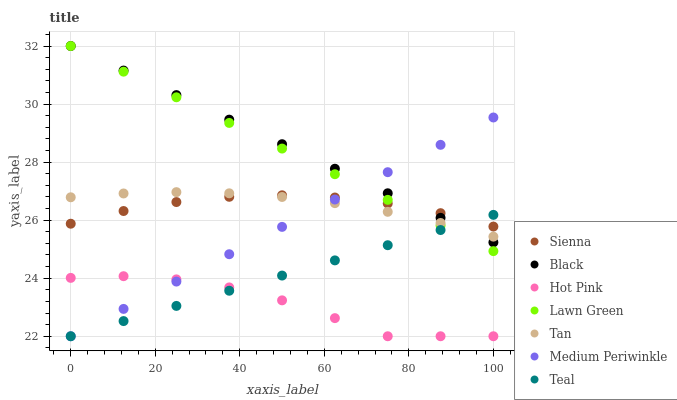Does Hot Pink have the minimum area under the curve?
Answer yes or no. Yes. Does Black have the maximum area under the curve?
Answer yes or no. Yes. Does Medium Periwinkle have the minimum area under the curve?
Answer yes or no. No. Does Medium Periwinkle have the maximum area under the curve?
Answer yes or no. No. Is Teal the smoothest?
Answer yes or no. Yes. Is Hot Pink the roughest?
Answer yes or no. Yes. Is Medium Periwinkle the smoothest?
Answer yes or no. No. Is Medium Periwinkle the roughest?
Answer yes or no. No. Does Hot Pink have the lowest value?
Answer yes or no. Yes. Does Sienna have the lowest value?
Answer yes or no. No. Does Black have the highest value?
Answer yes or no. Yes. Does Medium Periwinkle have the highest value?
Answer yes or no. No. Is Hot Pink less than Tan?
Answer yes or no. Yes. Is Sienna greater than Hot Pink?
Answer yes or no. Yes. Does Medium Periwinkle intersect Tan?
Answer yes or no. Yes. Is Medium Periwinkle less than Tan?
Answer yes or no. No. Is Medium Periwinkle greater than Tan?
Answer yes or no. No. Does Hot Pink intersect Tan?
Answer yes or no. No. 